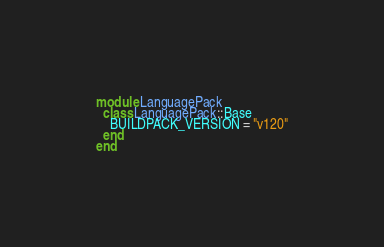Convert code to text. <code><loc_0><loc_0><loc_500><loc_500><_Ruby_>module LanguagePack
  class LanguagePack::Base
    BUILDPACK_VERSION = "v120"
  end
end
</code> 